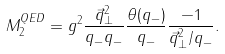<formula> <loc_0><loc_0><loc_500><loc_500>M ^ { Q E D } _ { 2 } = g ^ { 2 } \frac { \vec { q } ^ { 2 } _ { \perp } } { q _ { - } q _ { - } } \frac { \theta ( q _ { - } ) } { q _ { - } } \frac { - 1 } { \vec { q } ^ { 2 } _ { \perp } / q _ { - } } .</formula> 